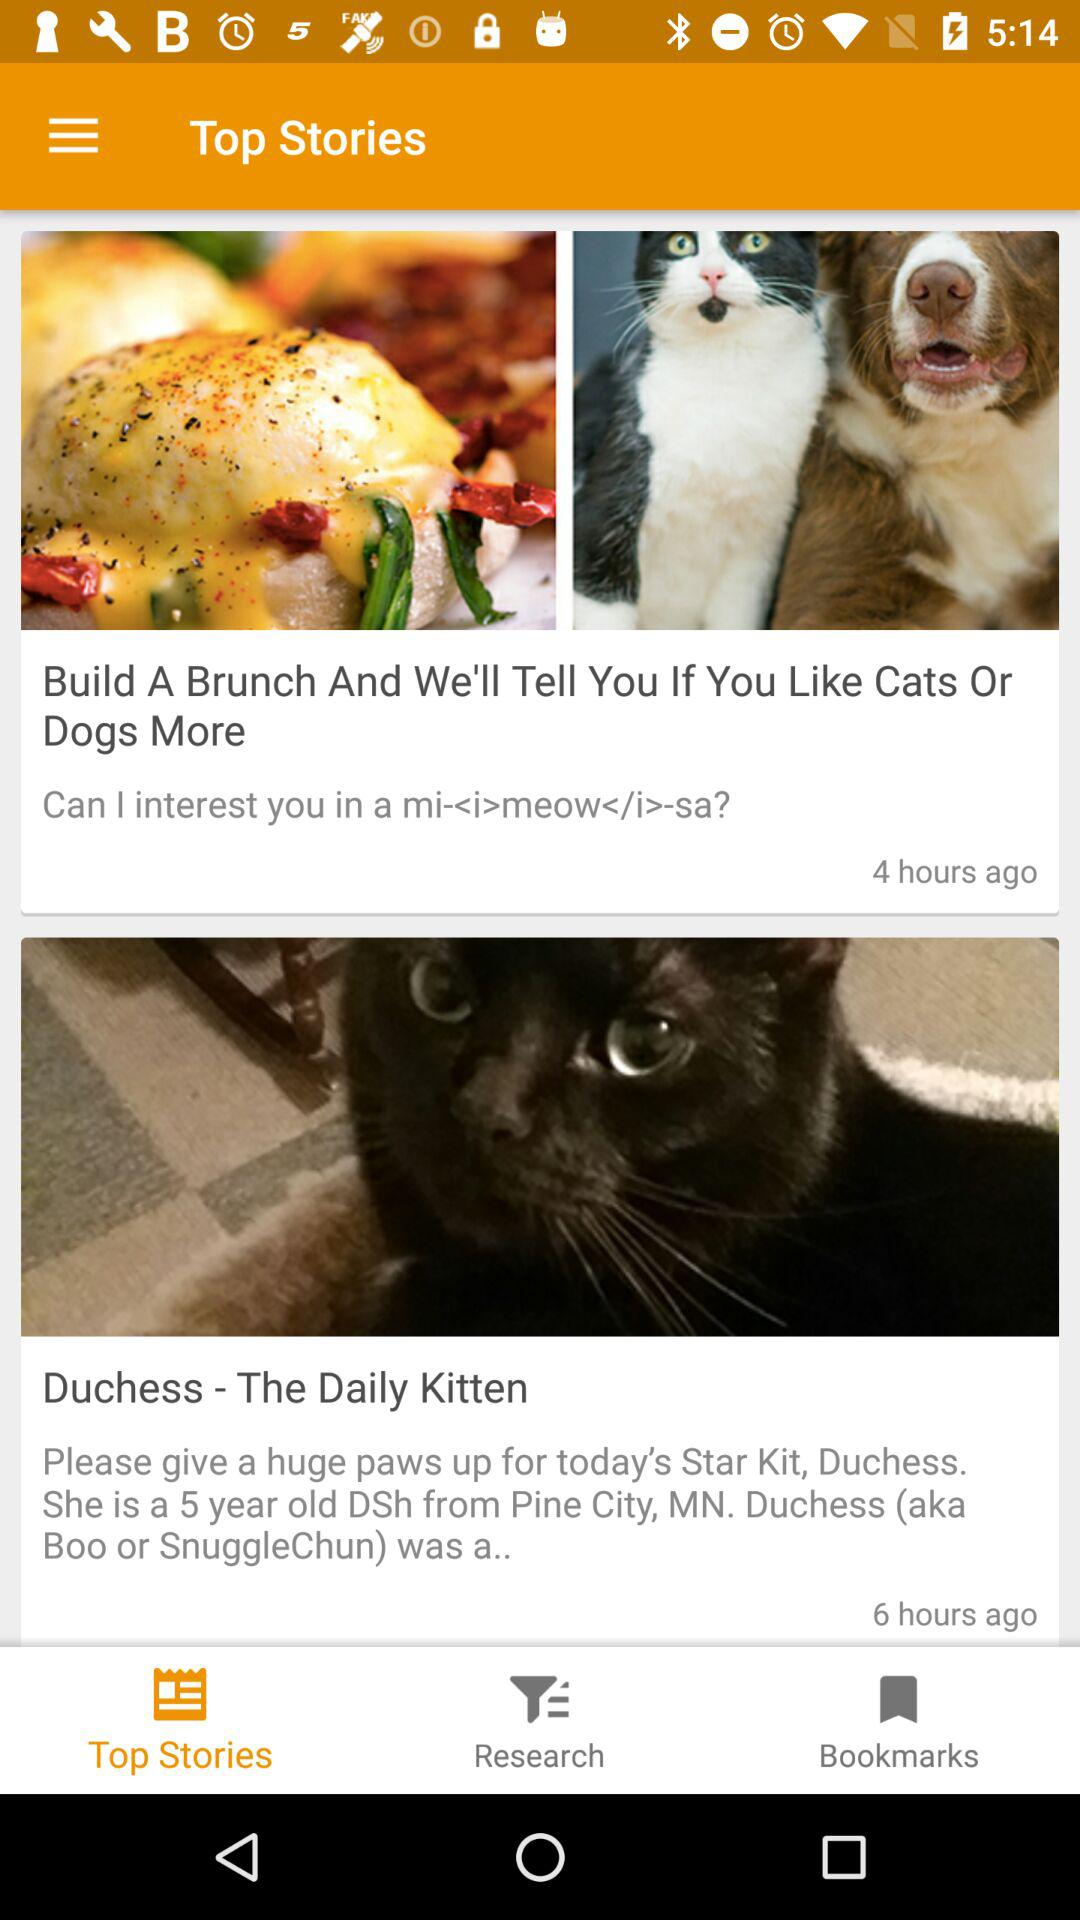When was the story "Build A Brunch And We'll Tell You If You Like Cats Or Dogs More" posted? The story "Build A Brunch And We'll Tell You If You Like Cats Or Dogs More" was posted 4 hours ago. 